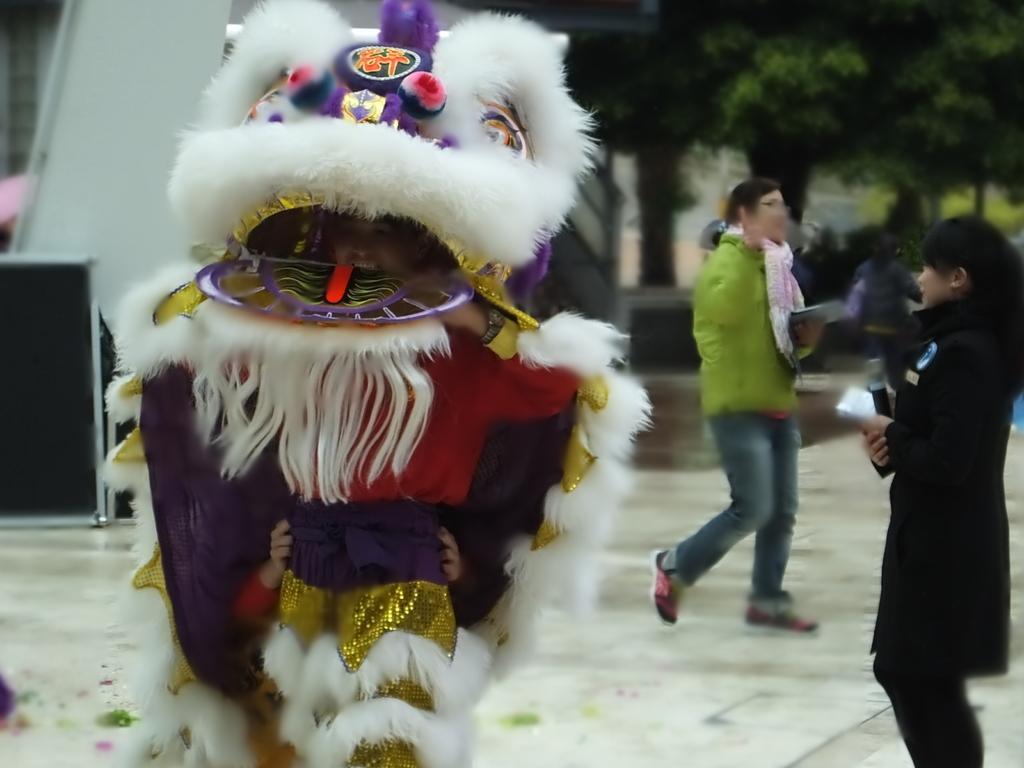Please provide a concise description of this image. This picture is taken from outside of the city. In this image, on the right side, we can see a woman wearing a black color dress and holding an object in her hand is standing. On the right side, we can also see another woman holding an object is walking on the road. On the left side, we can see a toy, in the toy, we can see the hand of a person. In the background, we can see a black color board, wall, trees and a group of people, at the bottom, we can see a floor. 